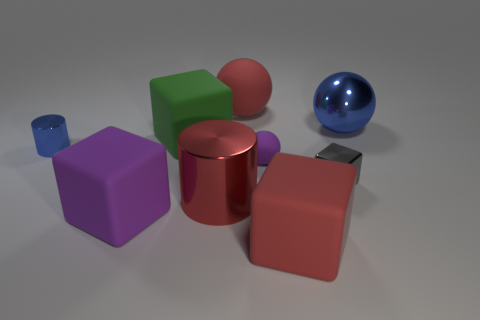Subtract all large red blocks. How many blocks are left? 3 Subtract all red blocks. How many blocks are left? 3 Subtract all balls. How many objects are left? 6 Subtract 3 cubes. How many cubes are left? 1 Add 7 blue metal spheres. How many blue metal spheres exist? 8 Subtract 0 blue blocks. How many objects are left? 9 Subtract all gray cylinders. Subtract all red blocks. How many cylinders are left? 2 Subtract all purple cylinders. How many green blocks are left? 1 Subtract all purple things. Subtract all large green things. How many objects are left? 6 Add 8 small purple rubber spheres. How many small purple rubber spheres are left? 9 